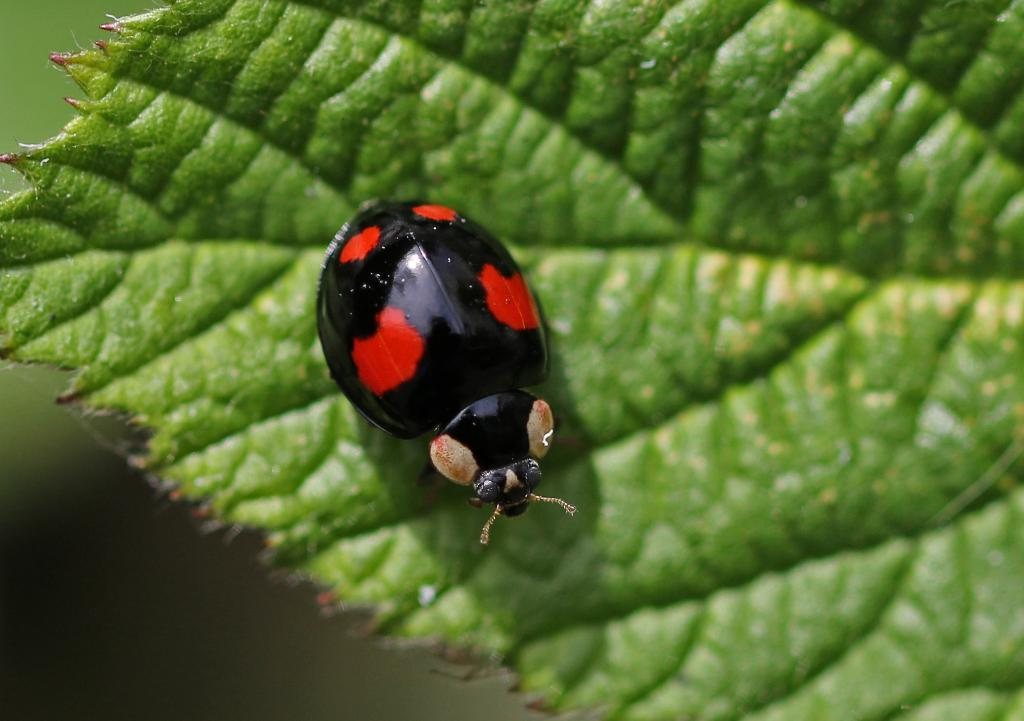What is present in the image? There is an insect in the image. Where is the insect located? The insect is on a leaf. What type of road can be seen in the image? There is no road present in the image; it features an insect on a leaf. How many dogs are visible in the image? There are no dogs present in the image; it features an insect on a leaf. 